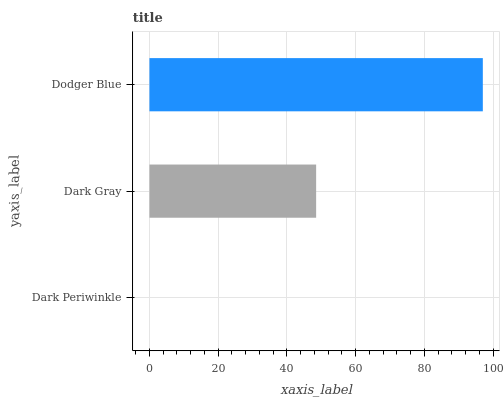Is Dark Periwinkle the minimum?
Answer yes or no. Yes. Is Dodger Blue the maximum?
Answer yes or no. Yes. Is Dark Gray the minimum?
Answer yes or no. No. Is Dark Gray the maximum?
Answer yes or no. No. Is Dark Gray greater than Dark Periwinkle?
Answer yes or no. Yes. Is Dark Periwinkle less than Dark Gray?
Answer yes or no. Yes. Is Dark Periwinkle greater than Dark Gray?
Answer yes or no. No. Is Dark Gray less than Dark Periwinkle?
Answer yes or no. No. Is Dark Gray the high median?
Answer yes or no. Yes. Is Dark Gray the low median?
Answer yes or no. Yes. Is Dodger Blue the high median?
Answer yes or no. No. Is Dark Periwinkle the low median?
Answer yes or no. No. 